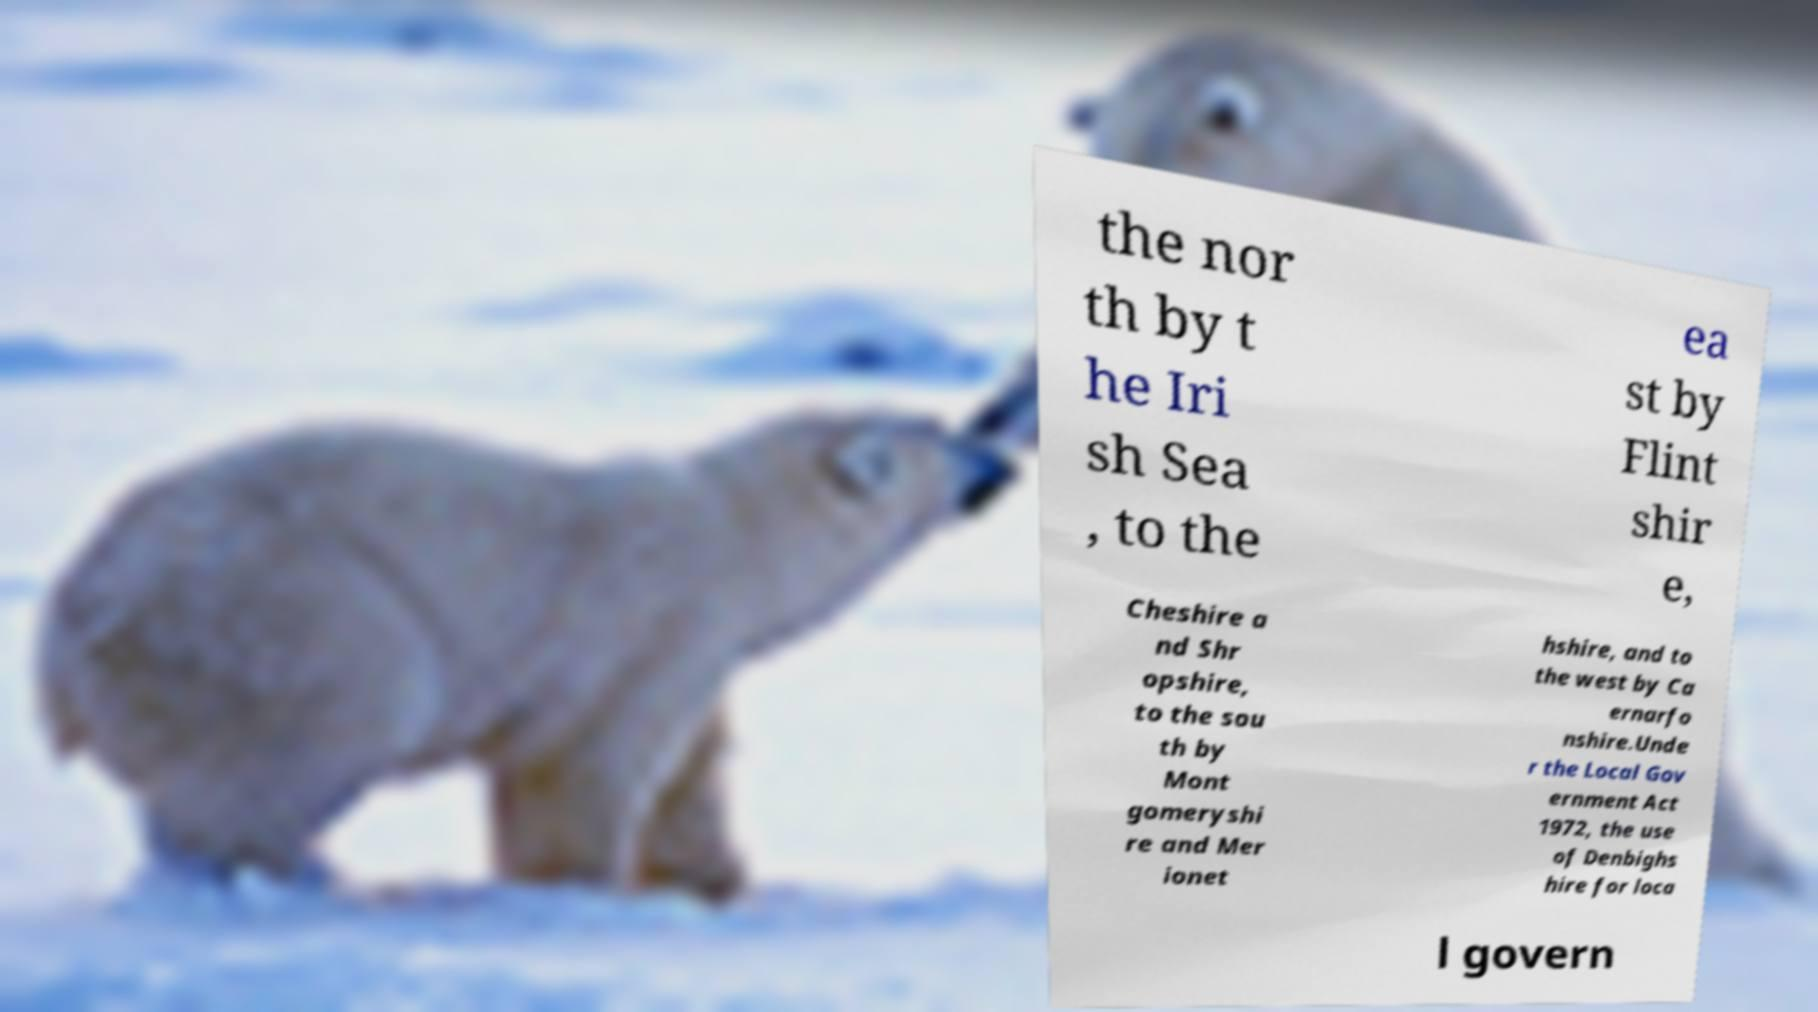Please identify and transcribe the text found in this image. the nor th by t he Iri sh Sea , to the ea st by Flint shir e, Cheshire a nd Shr opshire, to the sou th by Mont gomeryshi re and Mer ionet hshire, and to the west by Ca ernarfo nshire.Unde r the Local Gov ernment Act 1972, the use of Denbighs hire for loca l govern 